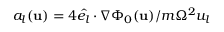<formula> <loc_0><loc_0><loc_500><loc_500>a _ { l } ( u ) = 4 \hat { e _ { l } } \cdot \nabla \Phi _ { 0 } ( u ) / m \Omega ^ { 2 } u _ { l }</formula> 